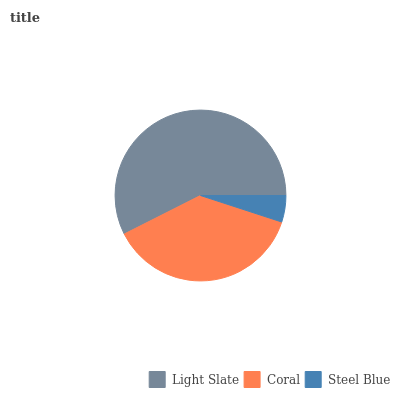Is Steel Blue the minimum?
Answer yes or no. Yes. Is Light Slate the maximum?
Answer yes or no. Yes. Is Coral the minimum?
Answer yes or no. No. Is Coral the maximum?
Answer yes or no. No. Is Light Slate greater than Coral?
Answer yes or no. Yes. Is Coral less than Light Slate?
Answer yes or no. Yes. Is Coral greater than Light Slate?
Answer yes or no. No. Is Light Slate less than Coral?
Answer yes or no. No. Is Coral the high median?
Answer yes or no. Yes. Is Coral the low median?
Answer yes or no. Yes. Is Light Slate the high median?
Answer yes or no. No. Is Light Slate the low median?
Answer yes or no. No. 